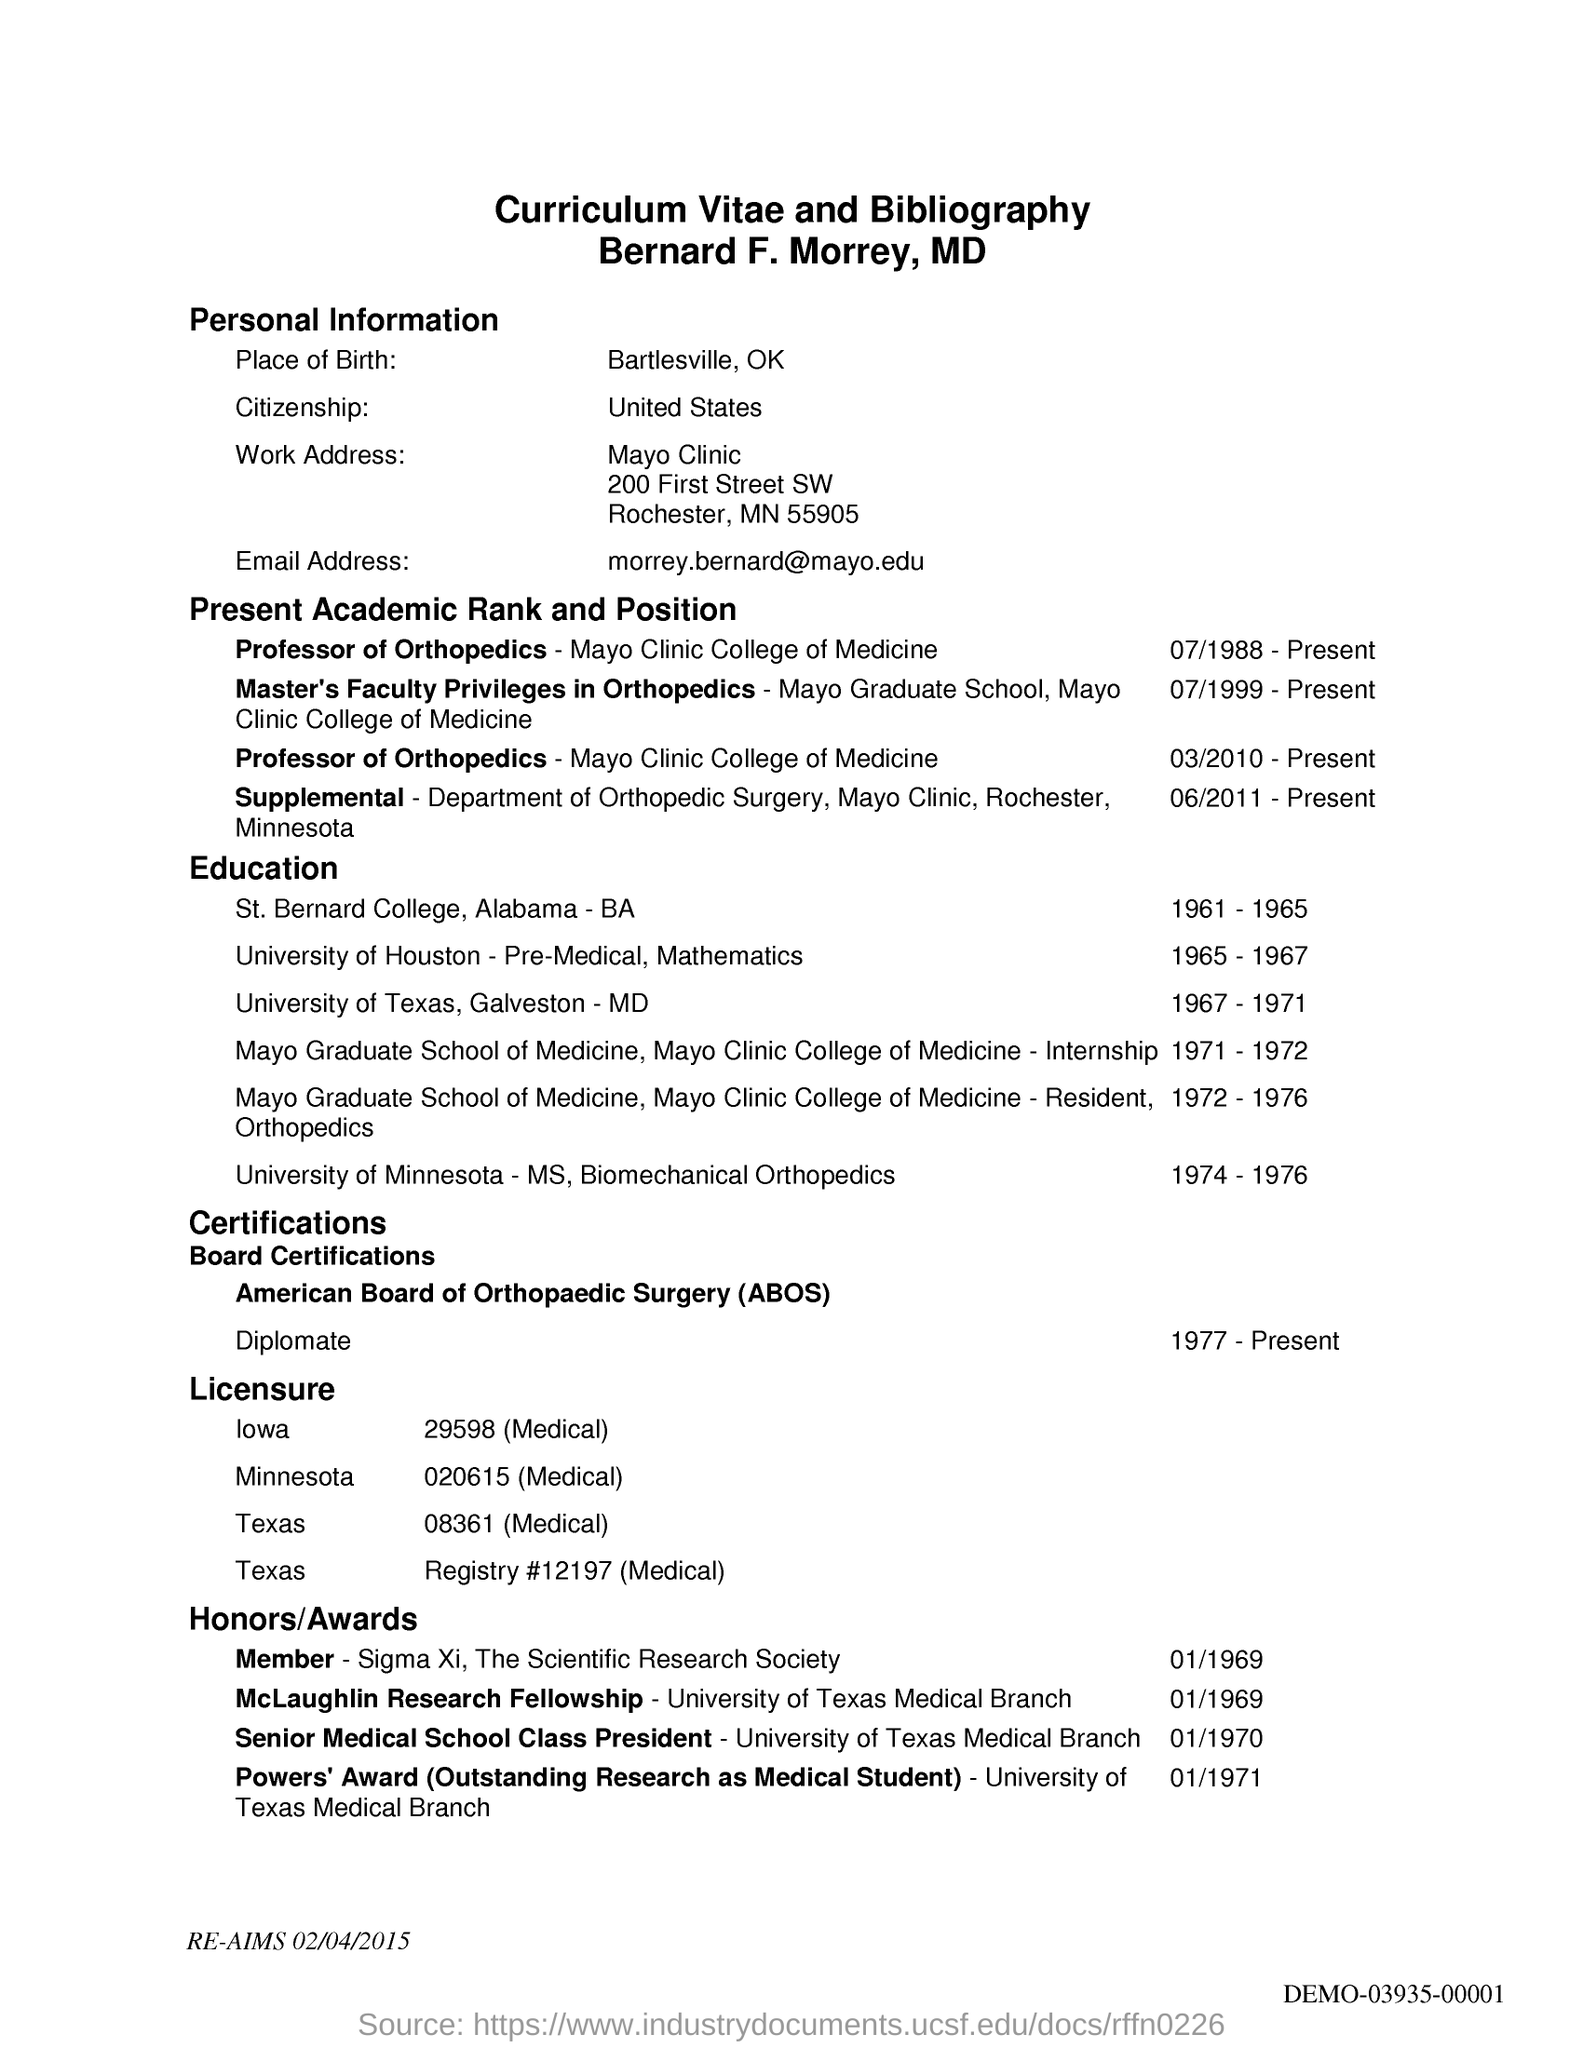Where is the place of birth of the applicant?
Ensure brevity in your answer.  Bartlesville, OK. What is the email address of the applicant?
Keep it short and to the point. Morrey.bernard@mayo.edu. What is the country of citizenship of the applicant?
Offer a very short reply. UNITED STATES. 